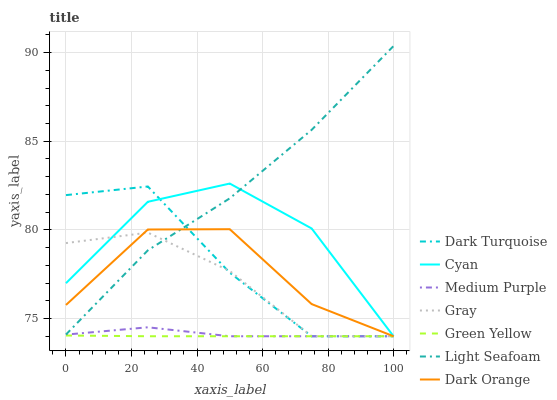Does Green Yellow have the minimum area under the curve?
Answer yes or no. Yes. Does Light Seafoam have the maximum area under the curve?
Answer yes or no. Yes. Does Dark Orange have the minimum area under the curve?
Answer yes or no. No. Does Dark Orange have the maximum area under the curve?
Answer yes or no. No. Is Green Yellow the smoothest?
Answer yes or no. Yes. Is Dark Orange the roughest?
Answer yes or no. Yes. Is Light Seafoam the smoothest?
Answer yes or no. No. Is Light Seafoam the roughest?
Answer yes or no. No. Does Gray have the lowest value?
Answer yes or no. Yes. Does Light Seafoam have the lowest value?
Answer yes or no. No. Does Light Seafoam have the highest value?
Answer yes or no. Yes. Does Dark Orange have the highest value?
Answer yes or no. No. Is Green Yellow less than Light Seafoam?
Answer yes or no. Yes. Is Light Seafoam greater than Medium Purple?
Answer yes or no. Yes. Does Dark Orange intersect Medium Purple?
Answer yes or no. Yes. Is Dark Orange less than Medium Purple?
Answer yes or no. No. Is Dark Orange greater than Medium Purple?
Answer yes or no. No. Does Green Yellow intersect Light Seafoam?
Answer yes or no. No. 